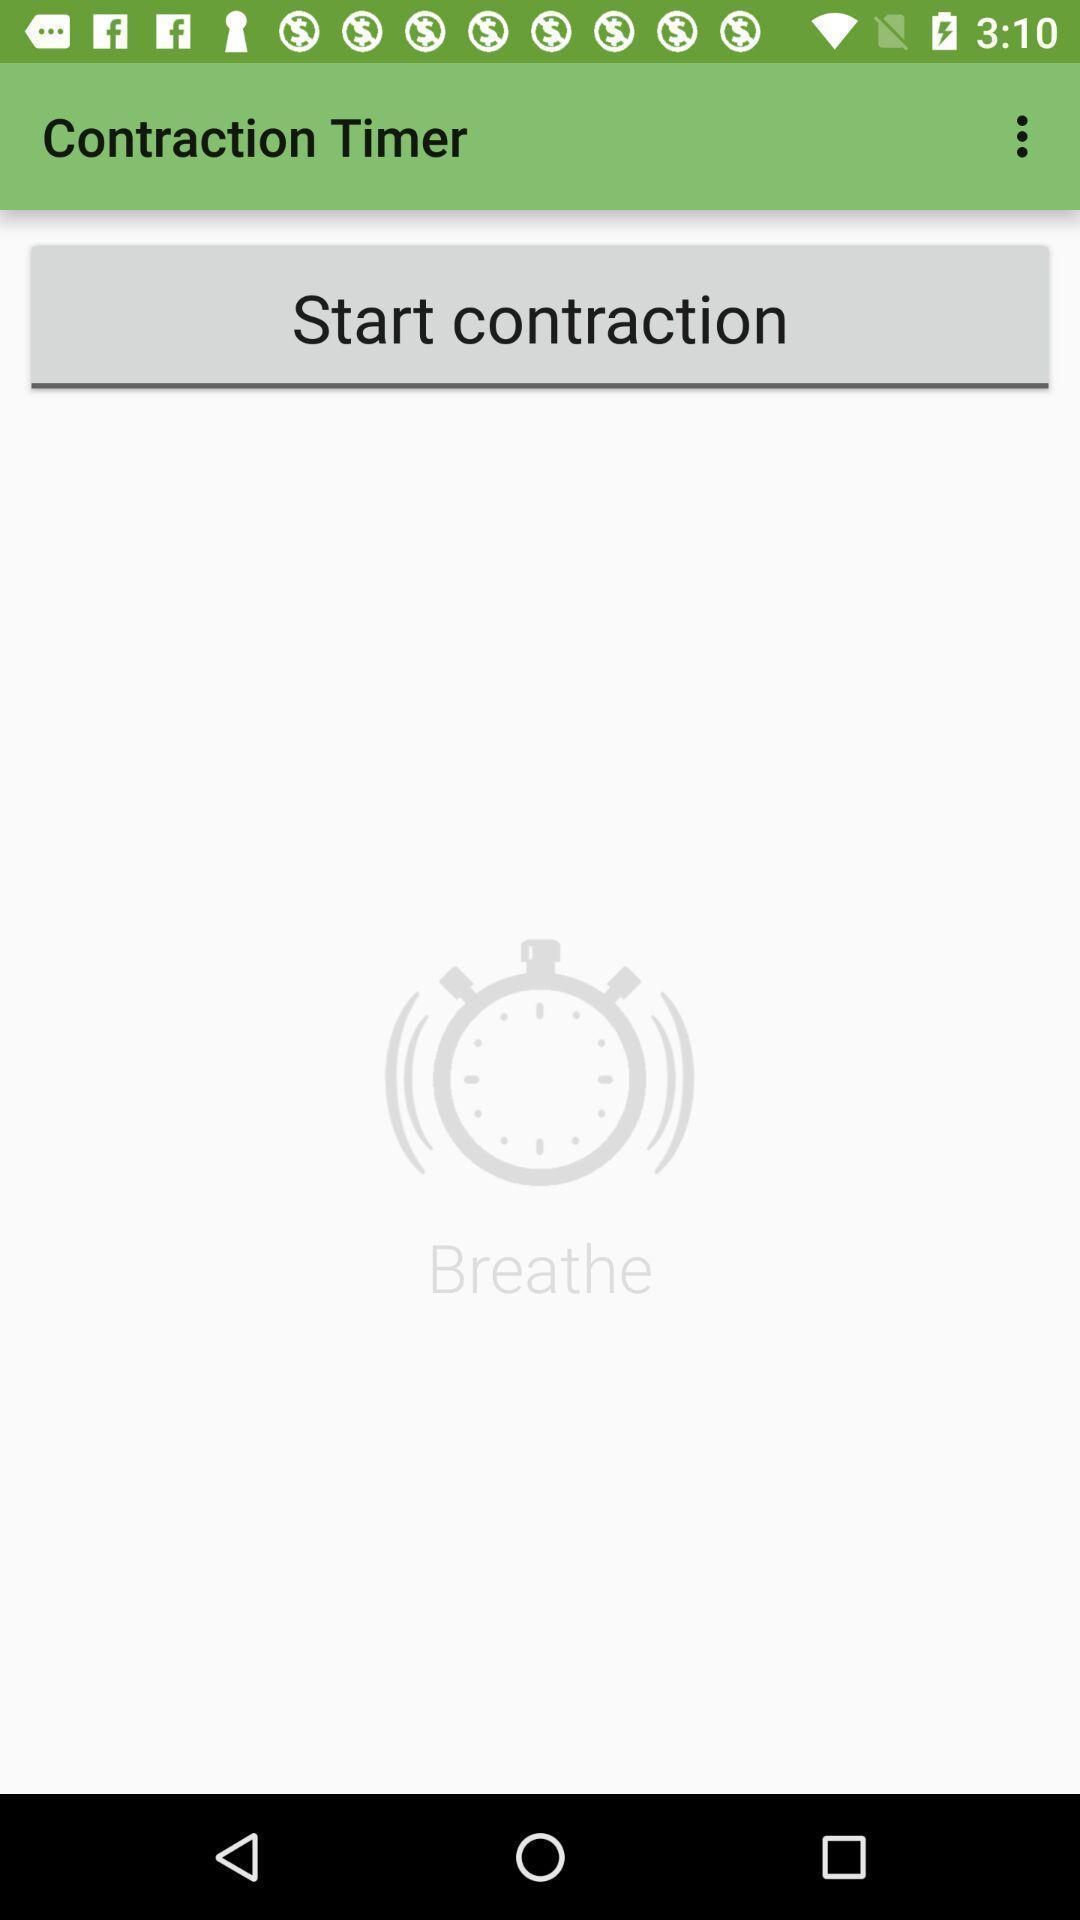What can you discern from this picture? Screen displaying contraction timer page. 